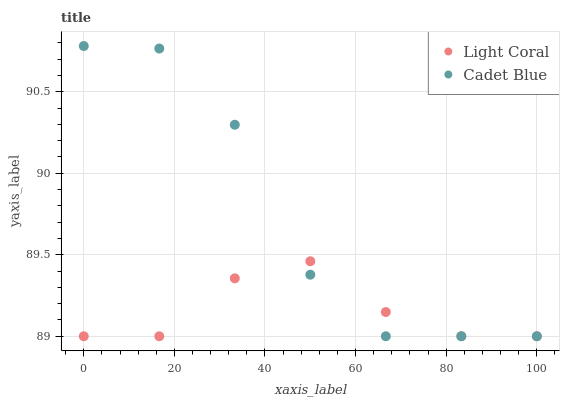Does Light Coral have the minimum area under the curve?
Answer yes or no. Yes. Does Cadet Blue have the maximum area under the curve?
Answer yes or no. Yes. Does Cadet Blue have the minimum area under the curve?
Answer yes or no. No. Is Light Coral the smoothest?
Answer yes or no. Yes. Is Cadet Blue the roughest?
Answer yes or no. Yes. Is Cadet Blue the smoothest?
Answer yes or no. No. Does Light Coral have the lowest value?
Answer yes or no. Yes. Does Cadet Blue have the highest value?
Answer yes or no. Yes. Does Light Coral intersect Cadet Blue?
Answer yes or no. Yes. Is Light Coral less than Cadet Blue?
Answer yes or no. No. Is Light Coral greater than Cadet Blue?
Answer yes or no. No. 